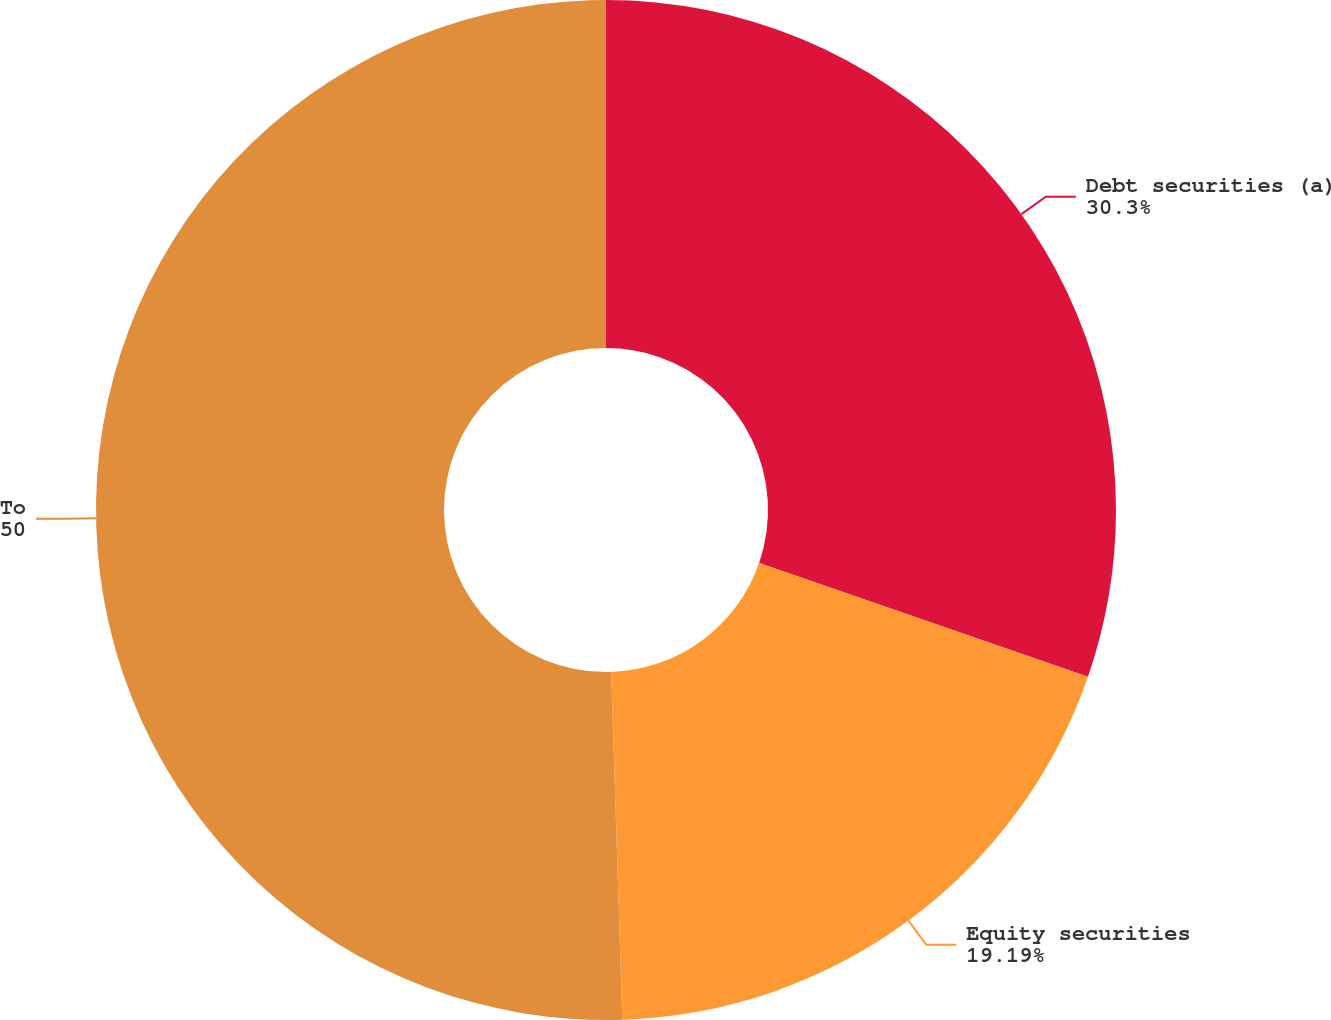Convert chart. <chart><loc_0><loc_0><loc_500><loc_500><pie_chart><fcel>Debt securities (a)<fcel>Equity securities<fcel>Total<nl><fcel>30.3%<fcel>19.19%<fcel>50.51%<nl></chart> 